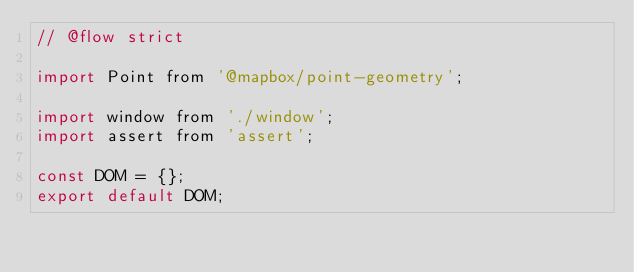<code> <loc_0><loc_0><loc_500><loc_500><_JavaScript_>// @flow strict

import Point from '@mapbox/point-geometry';

import window from './window';
import assert from 'assert';

const DOM = {};
export default DOM;
</code> 